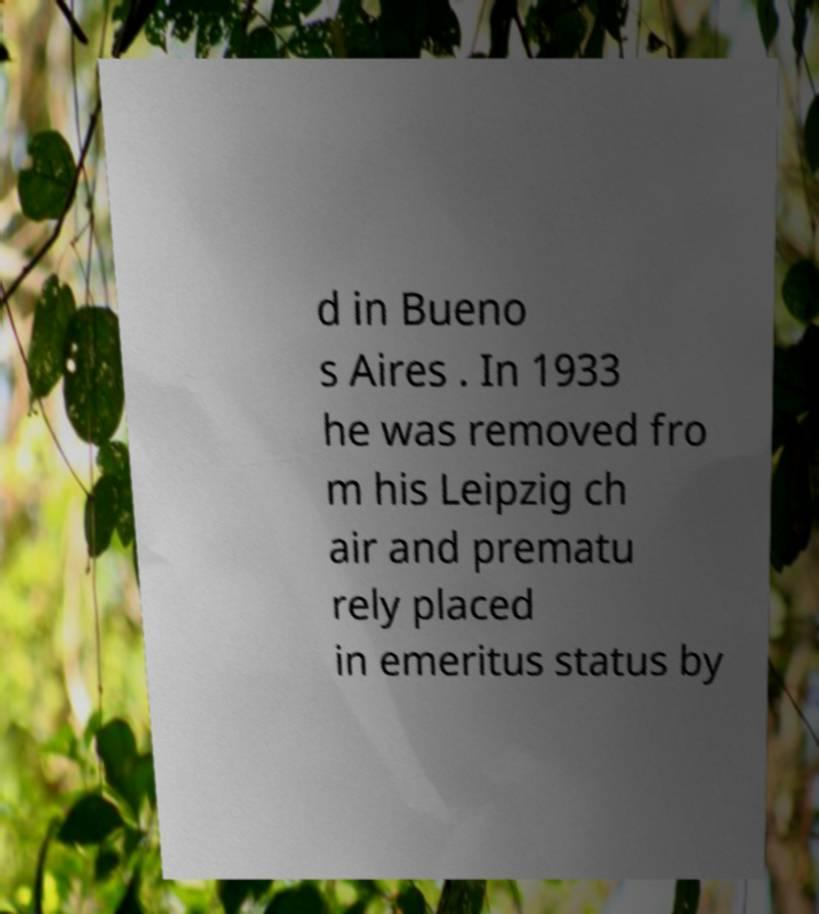Can you read and provide the text displayed in the image?This photo seems to have some interesting text. Can you extract and type it out for me? d in Bueno s Aires . In 1933 he was removed fro m his Leipzig ch air and prematu rely placed in emeritus status by 